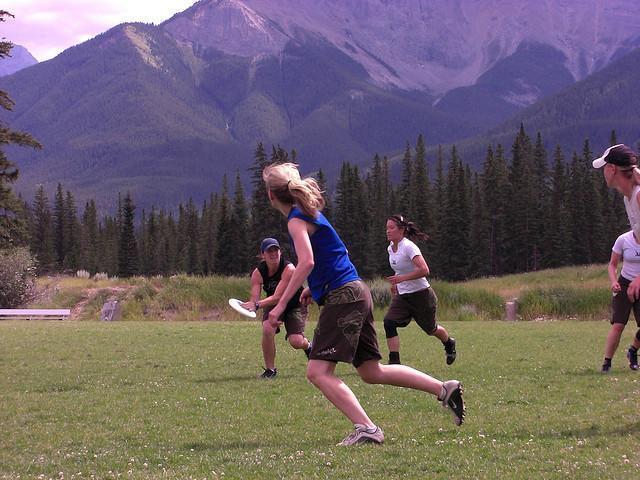How many people can you see?
Give a very brief answer. 5. How many cups are in the cup holder?
Give a very brief answer. 0. 